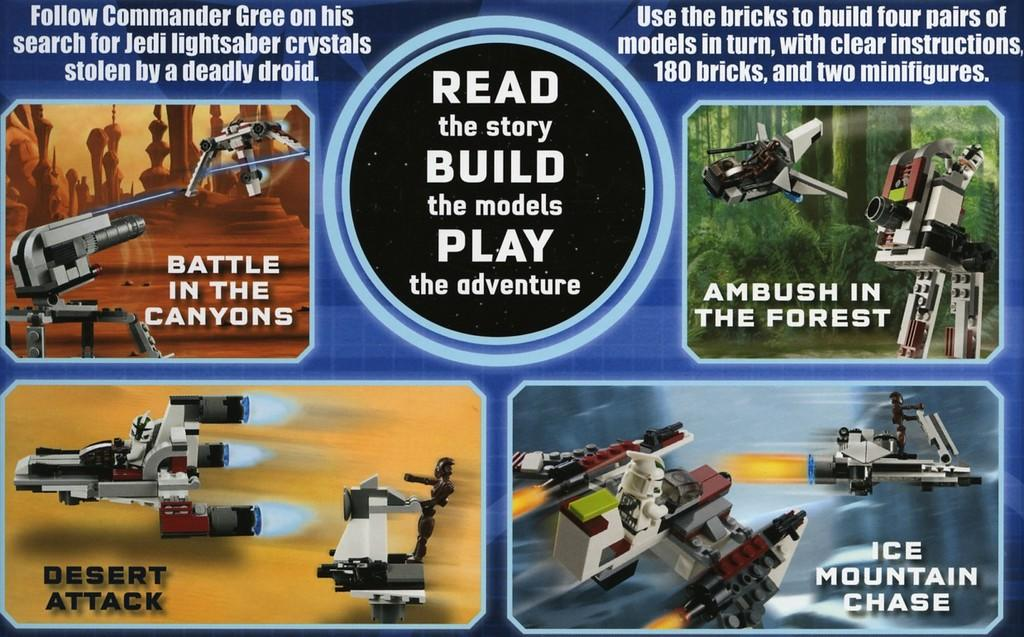<image>
Present a compact description of the photo's key features. Poster that says read the story, build the models, and play the adventure. 